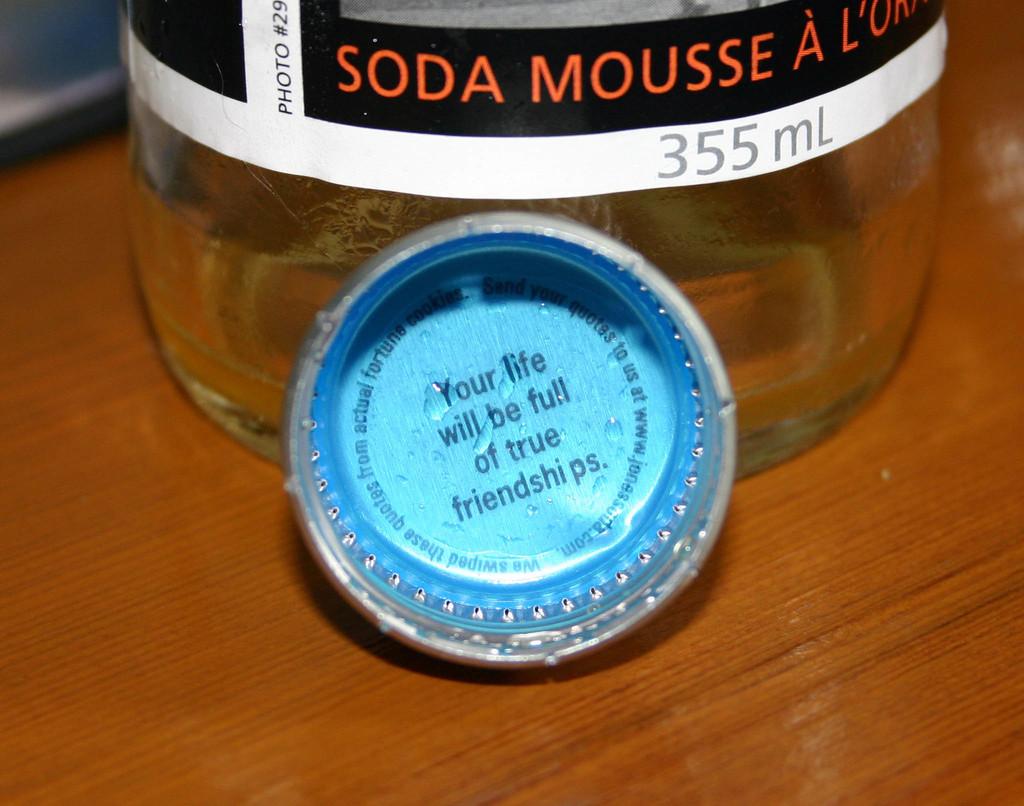How many ml does the bottle have?
Give a very brief answer. 355. What will your life be full of according to the cap?
Your response must be concise. True friendships. 